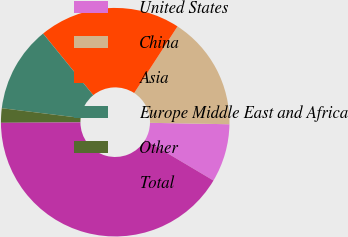Convert chart to OTSL. <chart><loc_0><loc_0><loc_500><loc_500><pie_chart><fcel>United States<fcel>China<fcel>Asia<fcel>Europe Middle East and Africa<fcel>Other<fcel>Total<nl><fcel>8.24%<fcel>16.11%<fcel>20.05%<fcel>12.18%<fcel>2.04%<fcel>41.39%<nl></chart> 